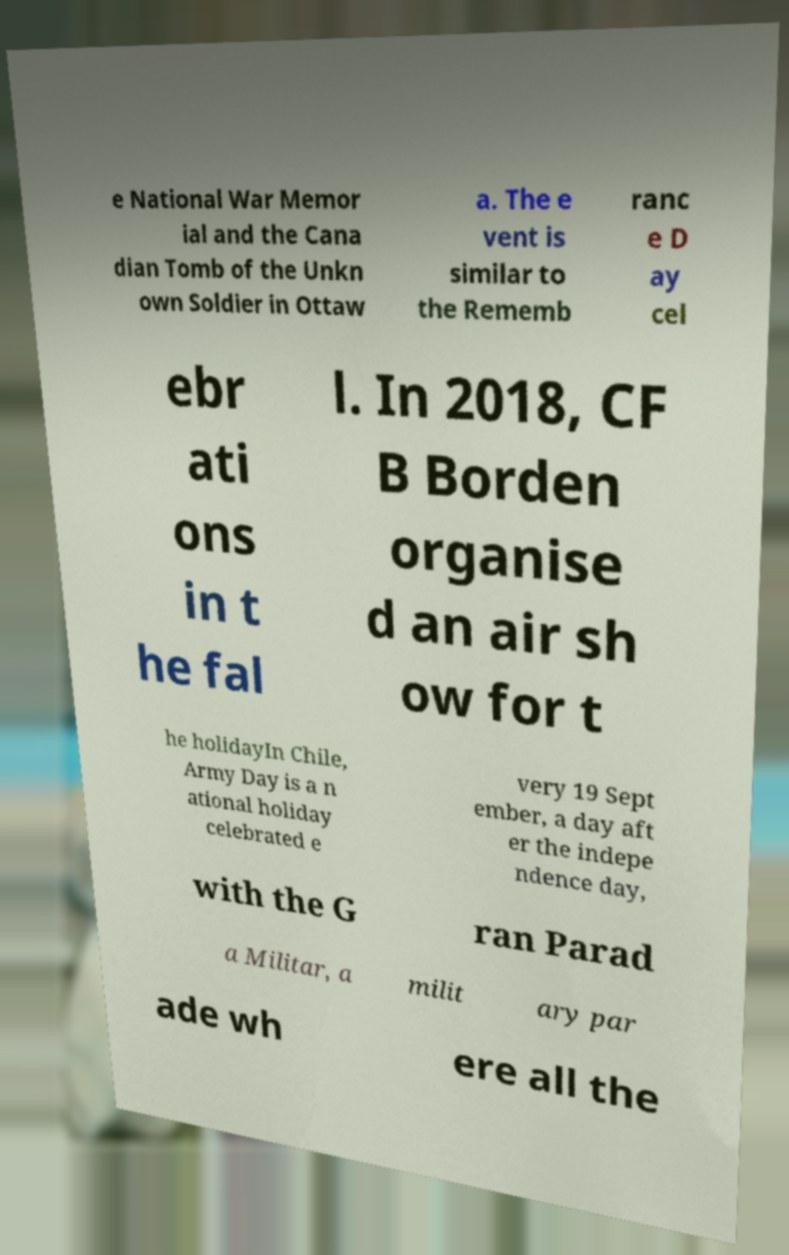For documentation purposes, I need the text within this image transcribed. Could you provide that? e National War Memor ial and the Cana dian Tomb of the Unkn own Soldier in Ottaw a. The e vent is similar to the Rememb ranc e D ay cel ebr ati ons in t he fal l. In 2018, CF B Borden organise d an air sh ow for t he holidayIn Chile, Army Day is a n ational holiday celebrated e very 19 Sept ember, a day aft er the indepe ndence day, with the G ran Parad a Militar, a milit ary par ade wh ere all the 